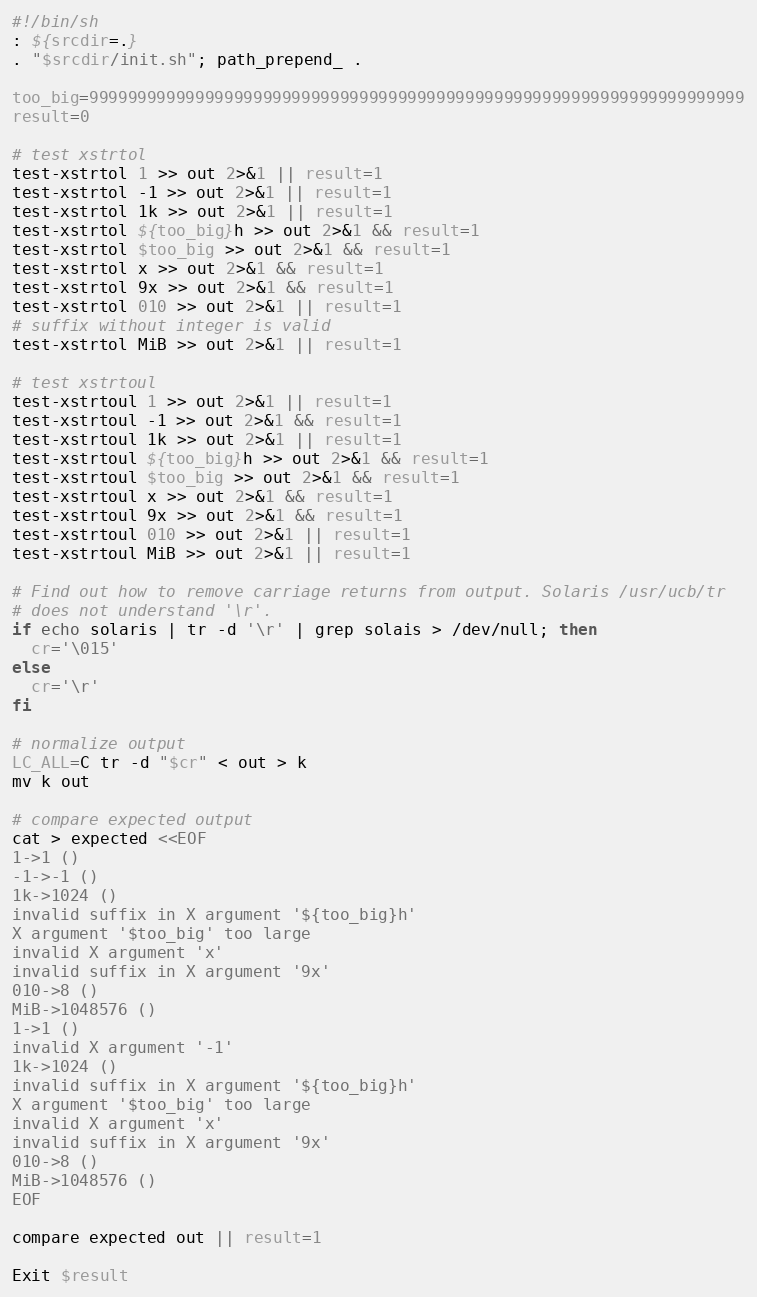Convert code to text. <code><loc_0><loc_0><loc_500><loc_500><_Bash_>#!/bin/sh
: ${srcdir=.}
. "$srcdir/init.sh"; path_prepend_ .

too_big=99999999999999999999999999999999999999999999999999999999999999999999
result=0

# test xstrtol
test-xstrtol 1 >> out 2>&1 || result=1
test-xstrtol -1 >> out 2>&1 || result=1
test-xstrtol 1k >> out 2>&1 || result=1
test-xstrtol ${too_big}h >> out 2>&1 && result=1
test-xstrtol $too_big >> out 2>&1 && result=1
test-xstrtol x >> out 2>&1 && result=1
test-xstrtol 9x >> out 2>&1 && result=1
test-xstrtol 010 >> out 2>&1 || result=1
# suffix without integer is valid
test-xstrtol MiB >> out 2>&1 || result=1

# test xstrtoul
test-xstrtoul 1 >> out 2>&1 || result=1
test-xstrtoul -1 >> out 2>&1 && result=1
test-xstrtoul 1k >> out 2>&1 || result=1
test-xstrtoul ${too_big}h >> out 2>&1 && result=1
test-xstrtoul $too_big >> out 2>&1 && result=1
test-xstrtoul x >> out 2>&1 && result=1
test-xstrtoul 9x >> out 2>&1 && result=1
test-xstrtoul 010 >> out 2>&1 || result=1
test-xstrtoul MiB >> out 2>&1 || result=1

# Find out how to remove carriage returns from output. Solaris /usr/ucb/tr
# does not understand '\r'.
if echo solaris | tr -d '\r' | grep solais > /dev/null; then
  cr='\015'
else
  cr='\r'
fi

# normalize output
LC_ALL=C tr -d "$cr" < out > k
mv k out

# compare expected output
cat > expected <<EOF
1->1 ()
-1->-1 ()
1k->1024 ()
invalid suffix in X argument '${too_big}h'
X argument '$too_big' too large
invalid X argument 'x'
invalid suffix in X argument '9x'
010->8 ()
MiB->1048576 ()
1->1 ()
invalid X argument '-1'
1k->1024 ()
invalid suffix in X argument '${too_big}h'
X argument '$too_big' too large
invalid X argument 'x'
invalid suffix in X argument '9x'
010->8 ()
MiB->1048576 ()
EOF

compare expected out || result=1

Exit $result
</code> 